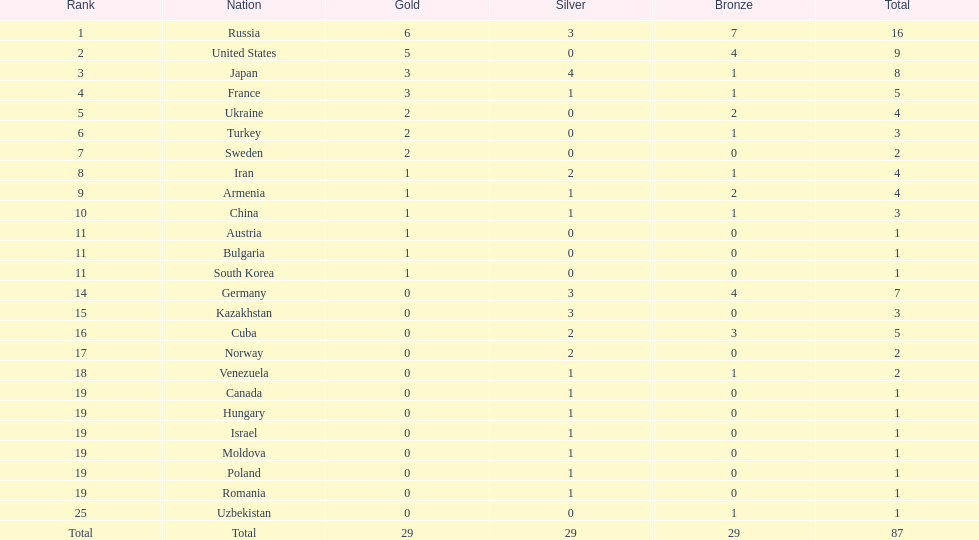Which place garnered the maximum quantity of medals? Russia. 